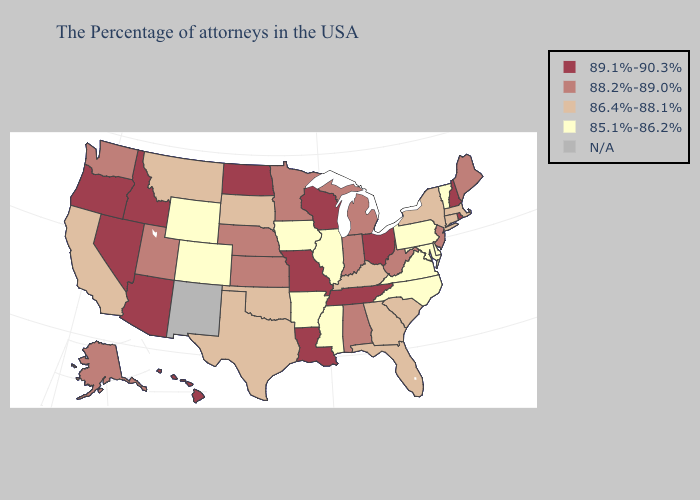Does the map have missing data?
Answer briefly. Yes. Among the states that border South Dakota , does Wyoming have the highest value?
Concise answer only. No. Name the states that have a value in the range N/A?
Write a very short answer. New Mexico. What is the value of South Carolina?
Concise answer only. 86.4%-88.1%. Does Georgia have the highest value in the South?
Write a very short answer. No. Does New Jersey have the lowest value in the Northeast?
Answer briefly. No. What is the lowest value in the Northeast?
Quick response, please. 85.1%-86.2%. Among the states that border Louisiana , which have the highest value?
Answer briefly. Texas. What is the value of North Dakota?
Keep it brief. 89.1%-90.3%. What is the value of Colorado?
Short answer required. 85.1%-86.2%. What is the value of Missouri?
Short answer required. 89.1%-90.3%. Does Mississippi have the highest value in the USA?
Be succinct. No. Is the legend a continuous bar?
Short answer required. No. 